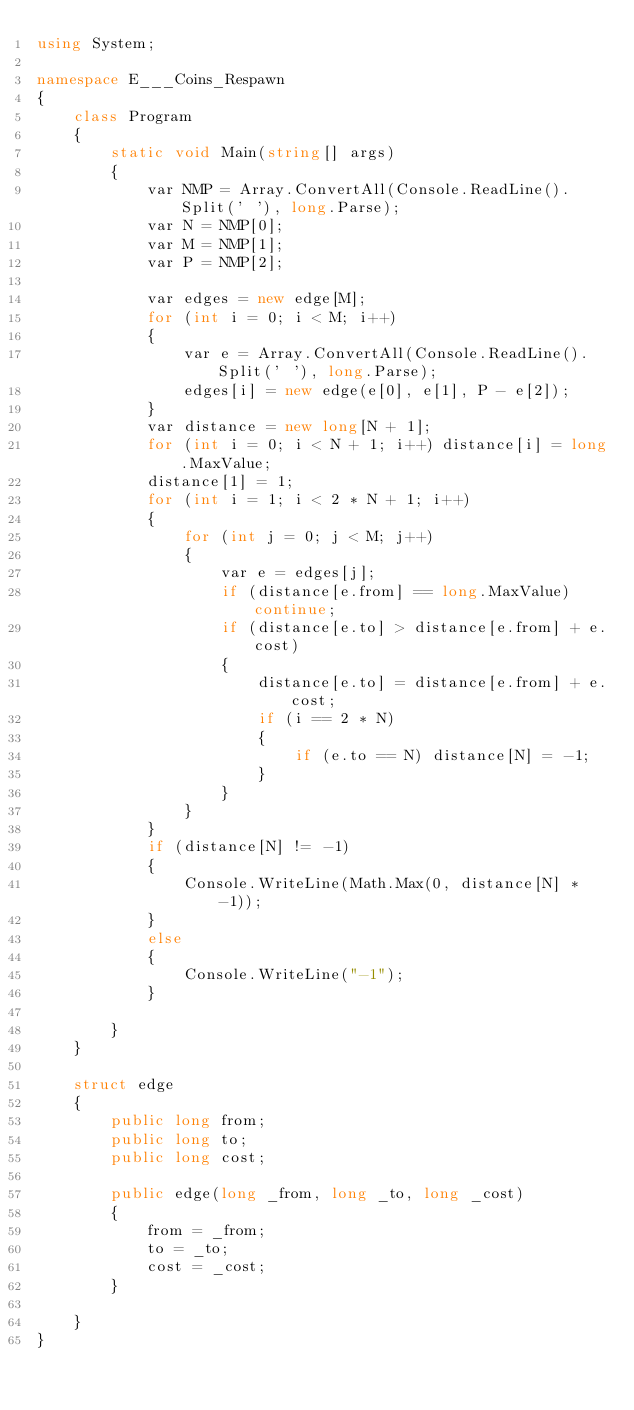Convert code to text. <code><loc_0><loc_0><loc_500><loc_500><_C#_>using System;

namespace E___Coins_Respawn
{
    class Program
    {
        static void Main(string[] args)
        {
            var NMP = Array.ConvertAll(Console.ReadLine().Split(' '), long.Parse);
            var N = NMP[0];
            var M = NMP[1];
            var P = NMP[2];

            var edges = new edge[M];
            for (int i = 0; i < M; i++)
            {
                var e = Array.ConvertAll(Console.ReadLine().Split(' '), long.Parse);
                edges[i] = new edge(e[0], e[1], P - e[2]);
            }
            var distance = new long[N + 1];
            for (int i = 0; i < N + 1; i++) distance[i] = long.MaxValue;
            distance[1] = 1;
            for (int i = 1; i < 2 * N + 1; i++)
            {
                for (int j = 0; j < M; j++)
                {
                    var e = edges[j];
                    if (distance[e.from] == long.MaxValue) continue;
                    if (distance[e.to] > distance[e.from] + e.cost)
                    {
                        distance[e.to] = distance[e.from] + e.cost;
                        if (i == 2 * N)
                        {
                            if (e.to == N) distance[N] = -1;
                        }
                    }
                }
            }
            if (distance[N] != -1)
            {
                Console.WriteLine(Math.Max(0, distance[N] * -1));
            }
            else
            {
                Console.WriteLine("-1");
            }

        }
    }

    struct edge
    {
        public long from;
        public long to;
        public long cost;

        public edge(long _from, long _to, long _cost)
        {
            from = _from;
            to = _to;
            cost = _cost;
        }

    }
}
</code> 